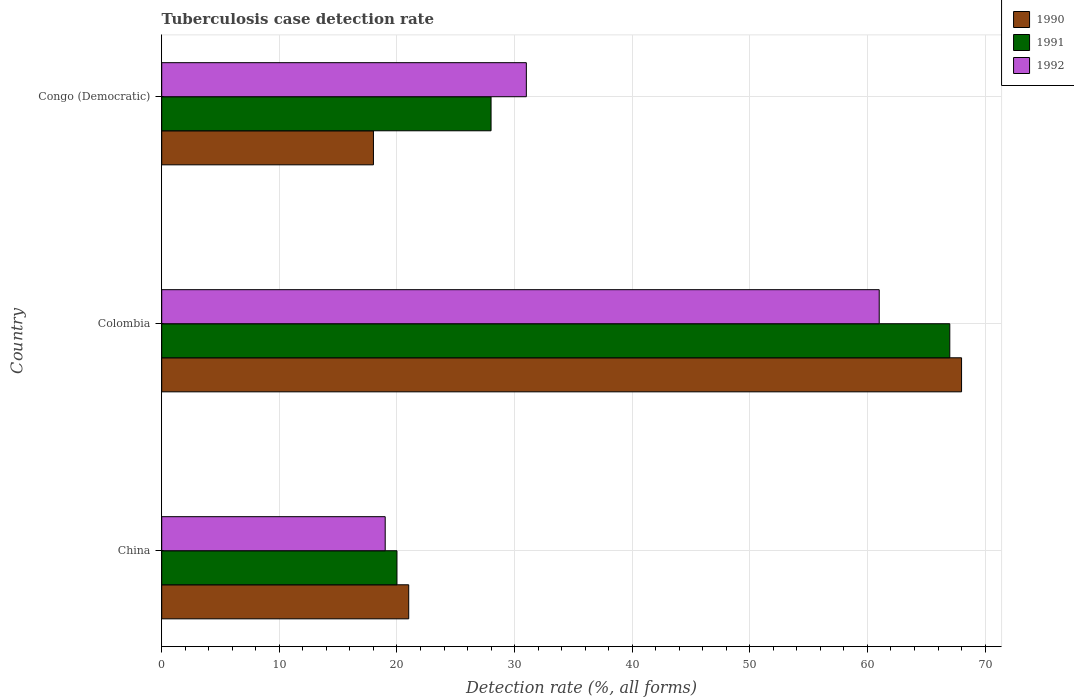How many groups of bars are there?
Offer a very short reply. 3. How many bars are there on the 2nd tick from the top?
Ensure brevity in your answer.  3. How many bars are there on the 2nd tick from the bottom?
Your response must be concise. 3. What is the label of the 2nd group of bars from the top?
Give a very brief answer. Colombia. In which country was the tuberculosis case detection rate in in 1991 maximum?
Offer a terse response. Colombia. In which country was the tuberculosis case detection rate in in 1992 minimum?
Ensure brevity in your answer.  China. What is the total tuberculosis case detection rate in in 1991 in the graph?
Provide a short and direct response. 115. What is the average tuberculosis case detection rate in in 1991 per country?
Ensure brevity in your answer.  38.33. What is the difference between the tuberculosis case detection rate in in 1992 and tuberculosis case detection rate in in 1990 in Congo (Democratic)?
Provide a short and direct response. 13. In how many countries, is the tuberculosis case detection rate in in 1992 greater than 48 %?
Ensure brevity in your answer.  1. What is the ratio of the tuberculosis case detection rate in in 1992 in Colombia to that in Congo (Democratic)?
Your answer should be very brief. 1.97. Is the difference between the tuberculosis case detection rate in in 1992 in China and Colombia greater than the difference between the tuberculosis case detection rate in in 1990 in China and Colombia?
Offer a very short reply. Yes. What is the difference between the highest and the second highest tuberculosis case detection rate in in 1991?
Offer a terse response. 39. In how many countries, is the tuberculosis case detection rate in in 1991 greater than the average tuberculosis case detection rate in in 1991 taken over all countries?
Provide a short and direct response. 1. Is the sum of the tuberculosis case detection rate in in 1992 in Colombia and Congo (Democratic) greater than the maximum tuberculosis case detection rate in in 1990 across all countries?
Provide a succinct answer. Yes. What does the 2nd bar from the top in Congo (Democratic) represents?
Ensure brevity in your answer.  1991. What does the 2nd bar from the bottom in China represents?
Offer a very short reply. 1991. How many bars are there?
Give a very brief answer. 9. How many countries are there in the graph?
Your response must be concise. 3. What is the difference between two consecutive major ticks on the X-axis?
Offer a terse response. 10. Are the values on the major ticks of X-axis written in scientific E-notation?
Give a very brief answer. No. Does the graph contain grids?
Keep it short and to the point. Yes. How are the legend labels stacked?
Offer a terse response. Vertical. What is the title of the graph?
Provide a short and direct response. Tuberculosis case detection rate. What is the label or title of the X-axis?
Provide a succinct answer. Detection rate (%, all forms). What is the Detection rate (%, all forms) in 1992 in China?
Give a very brief answer. 19. What is the Detection rate (%, all forms) in 1991 in Colombia?
Make the answer very short. 67. What is the Detection rate (%, all forms) in 1992 in Colombia?
Provide a short and direct response. 61. What is the Detection rate (%, all forms) of 1990 in Congo (Democratic)?
Provide a short and direct response. 18. What is the Detection rate (%, all forms) of 1991 in Congo (Democratic)?
Your answer should be very brief. 28. What is the Detection rate (%, all forms) of 1992 in Congo (Democratic)?
Provide a succinct answer. 31. Across all countries, what is the maximum Detection rate (%, all forms) in 1992?
Ensure brevity in your answer.  61. Across all countries, what is the minimum Detection rate (%, all forms) of 1991?
Give a very brief answer. 20. Across all countries, what is the minimum Detection rate (%, all forms) in 1992?
Provide a short and direct response. 19. What is the total Detection rate (%, all forms) in 1990 in the graph?
Your answer should be compact. 107. What is the total Detection rate (%, all forms) of 1991 in the graph?
Keep it short and to the point. 115. What is the total Detection rate (%, all forms) of 1992 in the graph?
Provide a succinct answer. 111. What is the difference between the Detection rate (%, all forms) in 1990 in China and that in Colombia?
Make the answer very short. -47. What is the difference between the Detection rate (%, all forms) in 1991 in China and that in Colombia?
Give a very brief answer. -47. What is the difference between the Detection rate (%, all forms) in 1992 in China and that in Colombia?
Offer a terse response. -42. What is the difference between the Detection rate (%, all forms) of 1992 in China and that in Congo (Democratic)?
Your answer should be very brief. -12. What is the difference between the Detection rate (%, all forms) in 1991 in Colombia and that in Congo (Democratic)?
Make the answer very short. 39. What is the difference between the Detection rate (%, all forms) in 1990 in China and the Detection rate (%, all forms) in 1991 in Colombia?
Offer a very short reply. -46. What is the difference between the Detection rate (%, all forms) in 1990 in China and the Detection rate (%, all forms) in 1992 in Colombia?
Give a very brief answer. -40. What is the difference between the Detection rate (%, all forms) in 1991 in China and the Detection rate (%, all forms) in 1992 in Colombia?
Keep it short and to the point. -41. What is the difference between the Detection rate (%, all forms) in 1990 in China and the Detection rate (%, all forms) in 1991 in Congo (Democratic)?
Make the answer very short. -7. What is the difference between the Detection rate (%, all forms) of 1990 in China and the Detection rate (%, all forms) of 1992 in Congo (Democratic)?
Provide a short and direct response. -10. What is the difference between the Detection rate (%, all forms) in 1991 in China and the Detection rate (%, all forms) in 1992 in Congo (Democratic)?
Offer a very short reply. -11. What is the average Detection rate (%, all forms) in 1990 per country?
Keep it short and to the point. 35.67. What is the average Detection rate (%, all forms) in 1991 per country?
Your response must be concise. 38.33. What is the average Detection rate (%, all forms) of 1992 per country?
Keep it short and to the point. 37. What is the difference between the Detection rate (%, all forms) in 1990 and Detection rate (%, all forms) in 1992 in China?
Give a very brief answer. 2. What is the difference between the Detection rate (%, all forms) of 1990 and Detection rate (%, all forms) of 1992 in Colombia?
Offer a very short reply. 7. What is the difference between the Detection rate (%, all forms) in 1990 and Detection rate (%, all forms) in 1991 in Congo (Democratic)?
Offer a very short reply. -10. What is the difference between the Detection rate (%, all forms) of 1990 and Detection rate (%, all forms) of 1992 in Congo (Democratic)?
Your answer should be compact. -13. What is the ratio of the Detection rate (%, all forms) in 1990 in China to that in Colombia?
Your response must be concise. 0.31. What is the ratio of the Detection rate (%, all forms) in 1991 in China to that in Colombia?
Your answer should be compact. 0.3. What is the ratio of the Detection rate (%, all forms) in 1992 in China to that in Colombia?
Provide a short and direct response. 0.31. What is the ratio of the Detection rate (%, all forms) of 1990 in China to that in Congo (Democratic)?
Give a very brief answer. 1.17. What is the ratio of the Detection rate (%, all forms) of 1991 in China to that in Congo (Democratic)?
Offer a terse response. 0.71. What is the ratio of the Detection rate (%, all forms) of 1992 in China to that in Congo (Democratic)?
Provide a succinct answer. 0.61. What is the ratio of the Detection rate (%, all forms) of 1990 in Colombia to that in Congo (Democratic)?
Offer a terse response. 3.78. What is the ratio of the Detection rate (%, all forms) in 1991 in Colombia to that in Congo (Democratic)?
Provide a short and direct response. 2.39. What is the ratio of the Detection rate (%, all forms) of 1992 in Colombia to that in Congo (Democratic)?
Keep it short and to the point. 1.97. What is the difference between the highest and the second highest Detection rate (%, all forms) of 1991?
Provide a short and direct response. 39. What is the difference between the highest and the lowest Detection rate (%, all forms) of 1990?
Give a very brief answer. 50. What is the difference between the highest and the lowest Detection rate (%, all forms) of 1992?
Your answer should be very brief. 42. 